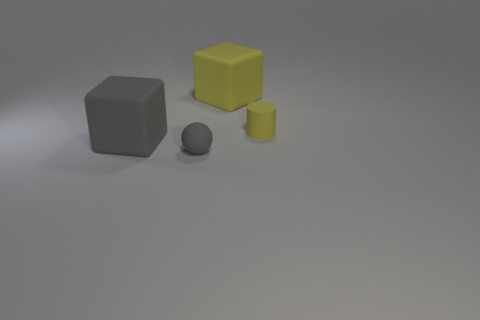What can you infer about the lighting in this scene? From the shadows and highlights, it seems that the lighting in this scene is coming from above and slightly to the right of the objects, creating soft shadows to the left, indicating a single diffuse light source. 